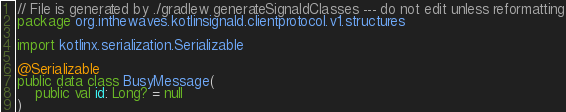<code> <loc_0><loc_0><loc_500><loc_500><_Kotlin_>// File is generated by ./gradlew generateSignaldClasses --- do not edit unless reformatting
package org.inthewaves.kotlinsignald.clientprotocol.v1.structures

import kotlinx.serialization.Serializable

@Serializable
public data class BusyMessage(
    public val id: Long? = null
)
</code> 